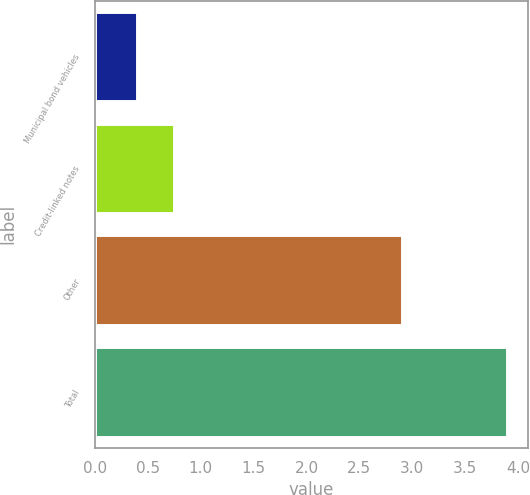<chart> <loc_0><loc_0><loc_500><loc_500><bar_chart><fcel>Municipal bond vehicles<fcel>Credit-linked notes<fcel>Other<fcel>Total<nl><fcel>0.4<fcel>0.75<fcel>2.9<fcel>3.9<nl></chart> 